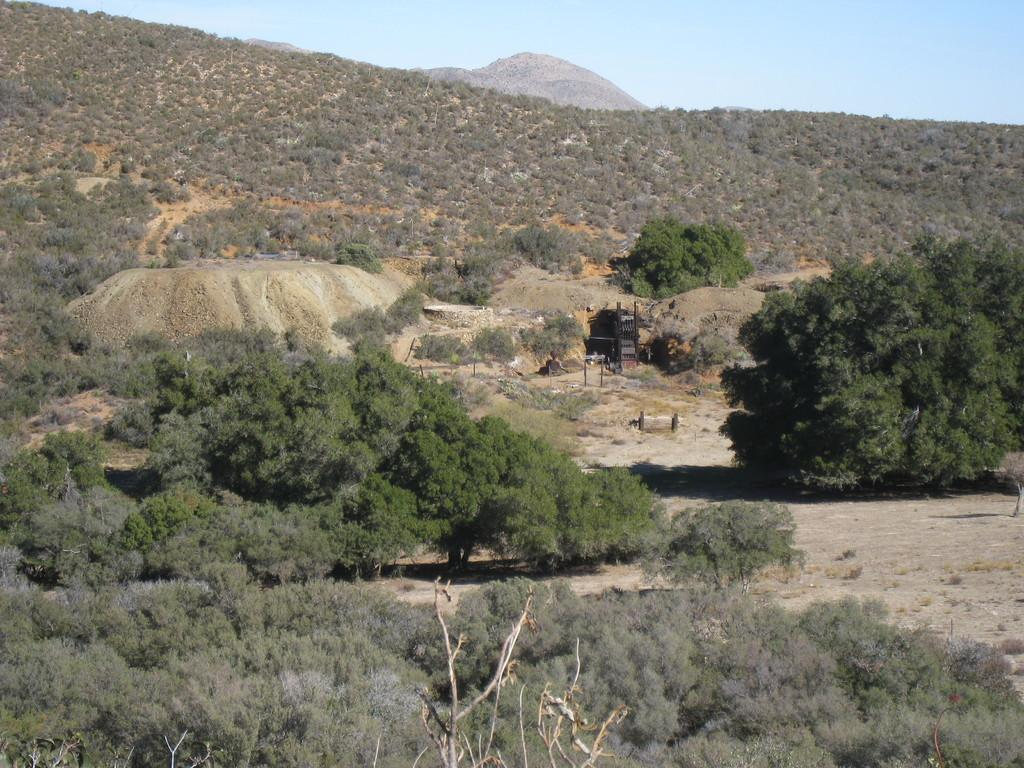What type of vegetation can be seen in the image? There are trees in the image. What geographical feature is visible at the top side of the image? There appears to be a mountain at the top side of the image. How many crows are perched on the trees in the image? There are no crows visible in the image; only trees and a mountain can be seen. What type of list is being referenced in the image? There is no list present in the image. 